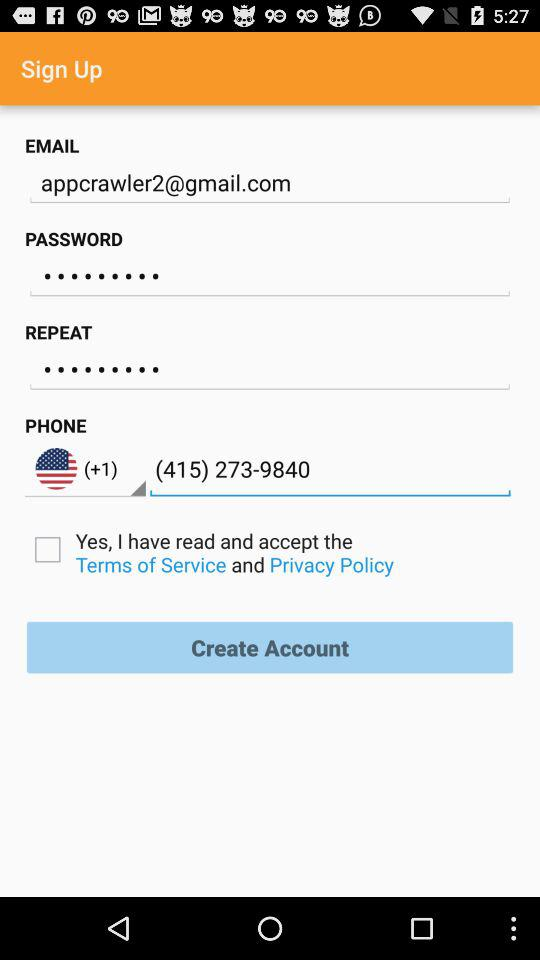What is the country code? The country code is +1. 